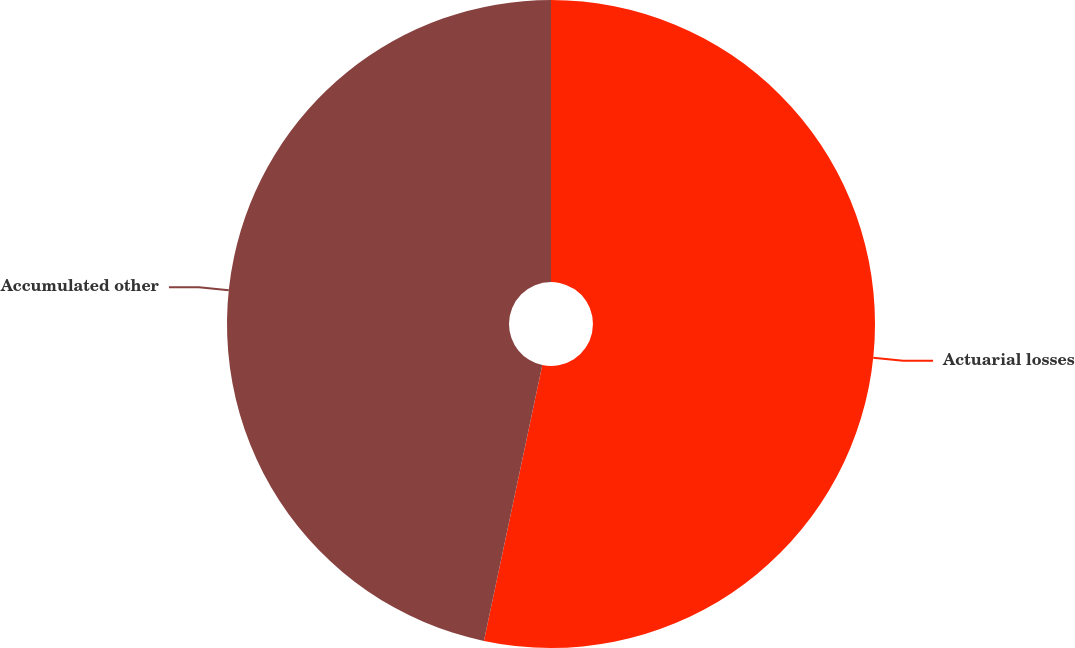Convert chart to OTSL. <chart><loc_0><loc_0><loc_500><loc_500><pie_chart><fcel>Actuarial losses<fcel>Accumulated other<nl><fcel>53.32%<fcel>46.68%<nl></chart> 